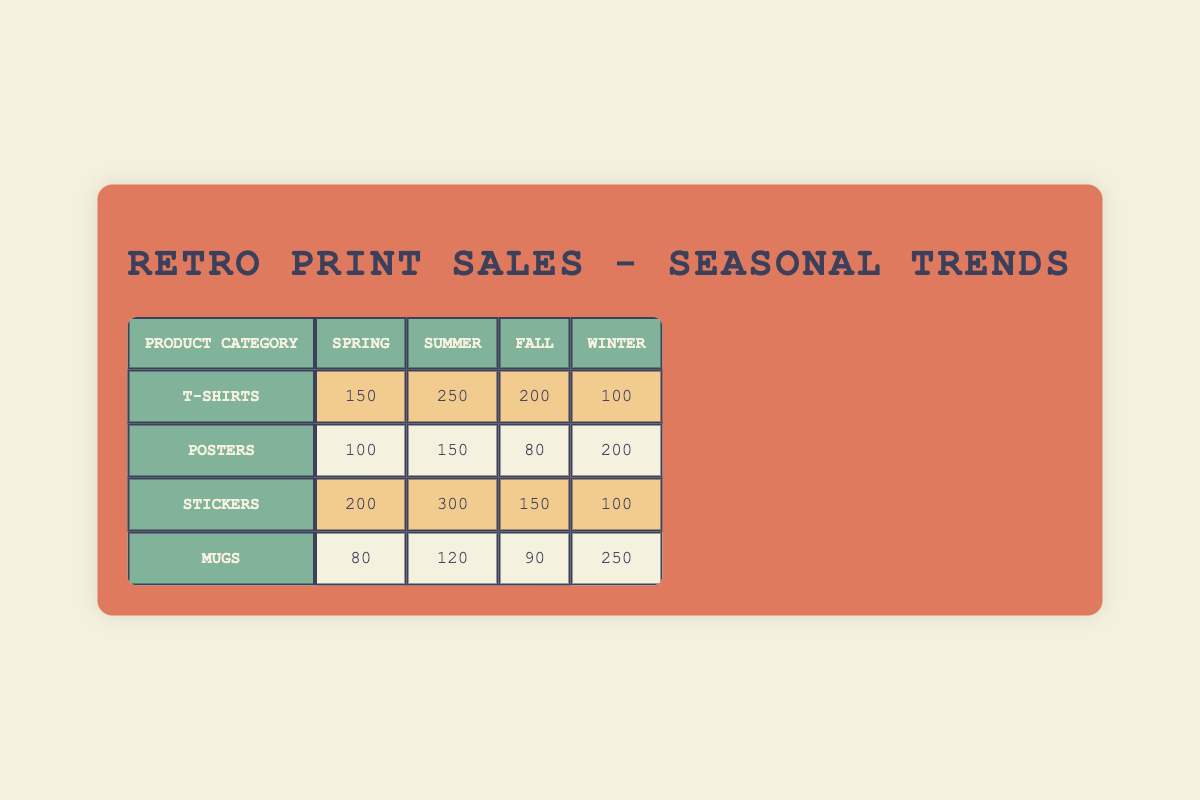What is the highest quantity of T-Shirts sold in a season? In the table, we look at the quantities of T-Shirts sold across all seasons. The values are: Spring 150, Summer 250, Fall 200, and Winter 100. The highest value is 250 in Summer.
Answer: 250 Which season saw the least sales of Posters? The sales volumes for Posters are: Spring 100, Summer 150, Fall 80, and Winter 200. The least quantity sold is 80 during the Fall season.
Answer: Fall What is the average quantity sold for Stickers across all seasons? The total quantities sold for Stickers are: Spring 200, Summer 300, Fall 150, and Winter 100. Summing these gives us 200 + 300 + 150 + 100 = 750. There are 4 seasons, so the average quantity sold is 750 / 4 = 187.5.
Answer: 187.5 Are more Mugs sold in Winter than in Spring? Looking at the Mugs sales, we find Spring has 80 sold and Winter has 250. Since 250 is greater than 80, the answer is yes.
Answer: Yes What is the total quantity sold across all seasons for Posters? To find the total sold for Posters, we add the values: Spring 100, Summer 150, Fall 80, and Winter 200. This totals 100 + 150 + 80 + 200 = 530.
Answer: 530 Which product category has the highest overall sales across all seasons? Summing the quantities sold for each product: T-Shirts = 150 + 250 + 200 + 100 = 700, Posters = 100 + 150 + 80 + 200 = 530, Stickers = 200 + 300 + 150 + 100 = 750, Mugs = 80 + 120 + 90 + 250 = 540. The highest total is for Stickers at 750.
Answer: Stickers What is the difference in sales volume between Summer and Winter for T-Shirts? The sales volume of T-Shirts in Summer is 250, while in Winter it is 100. The difference is calculated as 250 - 100 = 150.
Answer: 150 In which season are Stickers sold the most? From the data, the sales of Stickers in different seasons are: Spring 200, Summer 300, Fall 150, and Winter 100. The highest is 300 in Summer.
Answer: Summer 